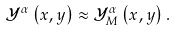<formula> <loc_0><loc_0><loc_500><loc_500>\mathcal { Y } ^ { \alpha } \left ( x , y \right ) \approx \mathcal { Y } ^ { \alpha } _ { M } \left ( x , y \right ) .</formula> 